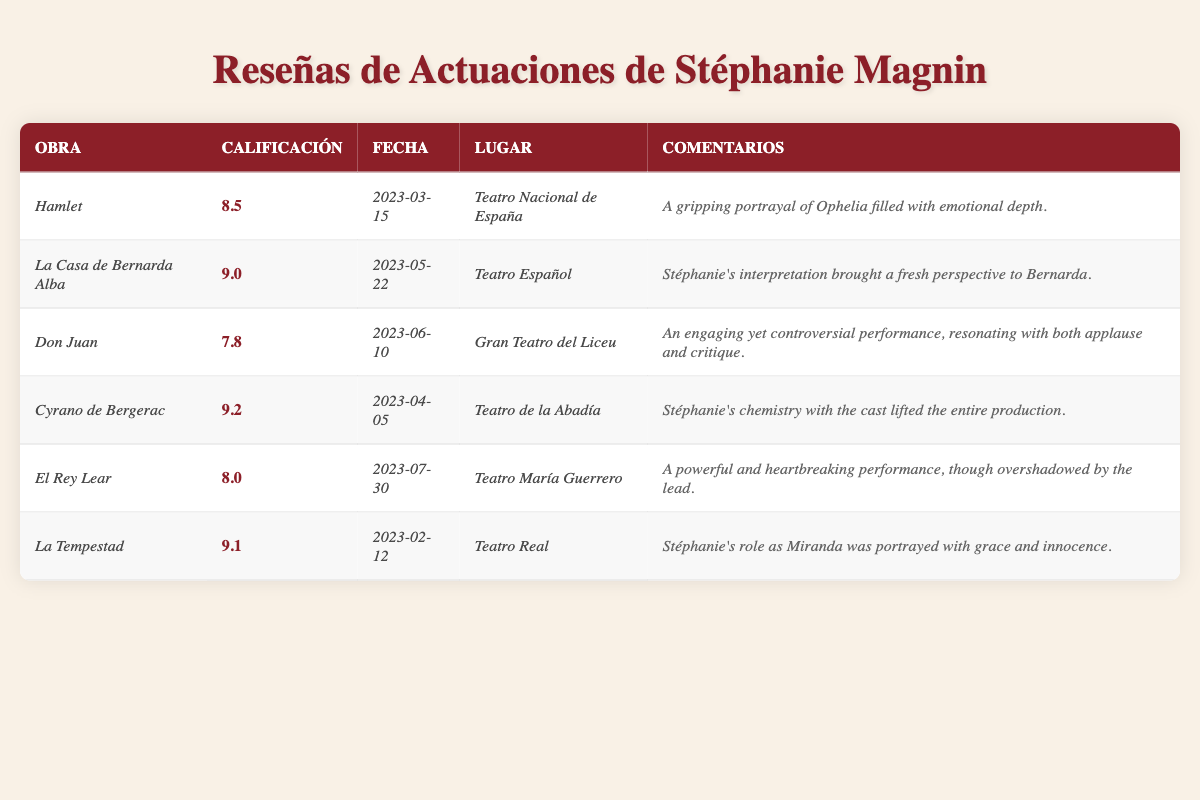What was Stéphanie's highest audience rating? The table lists audience ratings for each performance. By examining the ratings, *Cyrano de Bergerac* has the highest rating of 9.2.
Answer: 9.2 What performance took place at the *Teatro Español*? The table shows that *La Casa de Bernarda Alba* was performed at *Teatro Español*.
Answer: *La Casa de Bernarda Alba* How many performances received a rating of 9.0 or higher? The performances with ratings of 9.0 or higher are *La Casa de Bernarda Alba* (9.0), *Cyrano de Bergerac* (9.2), and *La Tempestad* (9.1), totaling three performances.
Answer: 3 What is the average audience rating across all performances? To find the average, sum the ratings (8.5 + 9.0 + 7.8 + 9.2 + 8.0 + 9.1 = 51.6) and divide by the total performances (6), resulting in an average of 51.6/6 = 8.6.
Answer: 8.6 Was there any performance that received a rating below 8.0? Yes, the performance *Don Juan* received a rating of 7.8, which is below 8.0.
Answer: Yes Which two performances had the closest audience ratings? Comparing the ratings, *El Rey Lear* (8.0) and *Hamlet* (8.5) have the smallest difference of 0.5.
Answer: *El Rey Lear* and *Hamlet* On what date was *La Tempestad* performed? The table indicates that *La Tempestad* was performed on 2023-02-12.
Answer: 2023-02-12 Did Stéphanie perform in more than one show in March 2023? No, she only performed in *Hamlet* in March 2023 on the 15th.
Answer: No What show had the most positive comments described in the reviews? The comments for *Cyrano de Bergerac* express that Stéphanie's chemistry with the cast made the production exceptional, suggesting the most positive feedback overall.
Answer: *Cyrano de Bergerac* How did the audience rate Stéphanie's performance in *Don Juan*? The audience rated her performance in *Don Juan* with a score of 7.8, reflecting mixed feedback.
Answer: 7.8 Which performance was described as powerful yet overshadowed by the lead? The performance described this way is *El Rey Lear*, indicating that while powerful, it did not receive as much attention compared to the lead actor.
Answer: *El Rey Lear* 